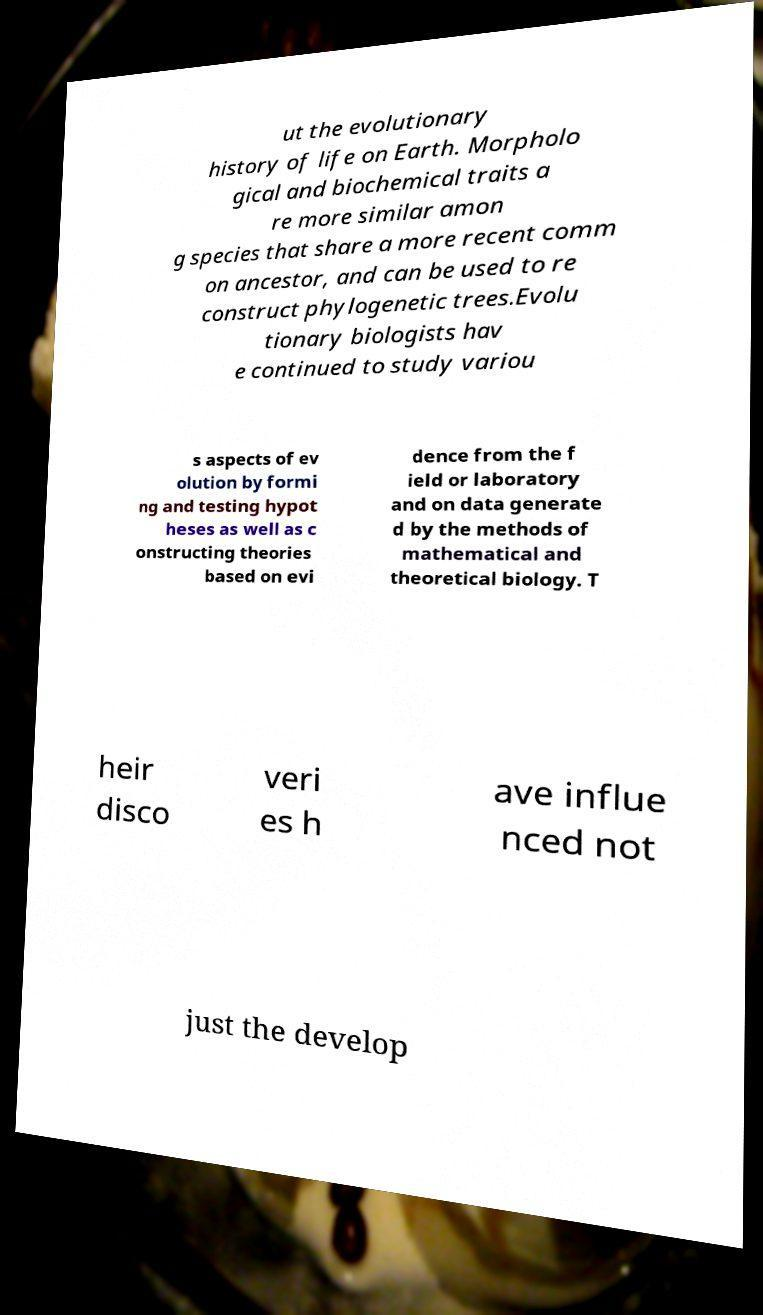Please read and relay the text visible in this image. What does it say? ut the evolutionary history of life on Earth. Morpholo gical and biochemical traits a re more similar amon g species that share a more recent comm on ancestor, and can be used to re construct phylogenetic trees.Evolu tionary biologists hav e continued to study variou s aspects of ev olution by formi ng and testing hypot heses as well as c onstructing theories based on evi dence from the f ield or laboratory and on data generate d by the methods of mathematical and theoretical biology. T heir disco veri es h ave influe nced not just the develop 